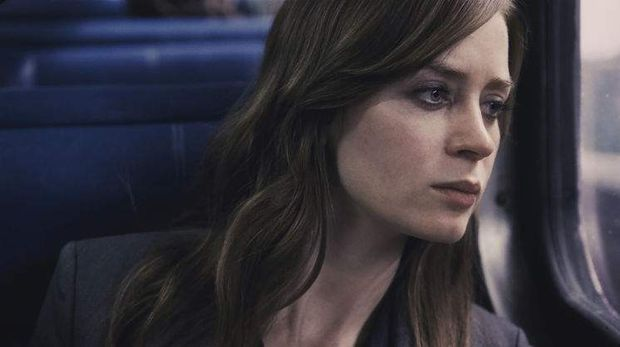Can you elaborate on the elements of the picture provided? This image features a woman, portrayed with a somber and reflective expression, seated inside a train. She is gazing out of the window, which subtly reflects her thoughtful state. Her hairstyle, loose waves, complements the introspective aura. She wears a gray blazer that blends with the train's interior, marked by muted blues and grays, suggesting a cool or overcast weather outside. This setting invokes a sense of solitude and contemplation, hinting at a narrative of personal journey or emotional introspection, typical of complex character-driven stories like ‘The Girl on the Train’. 